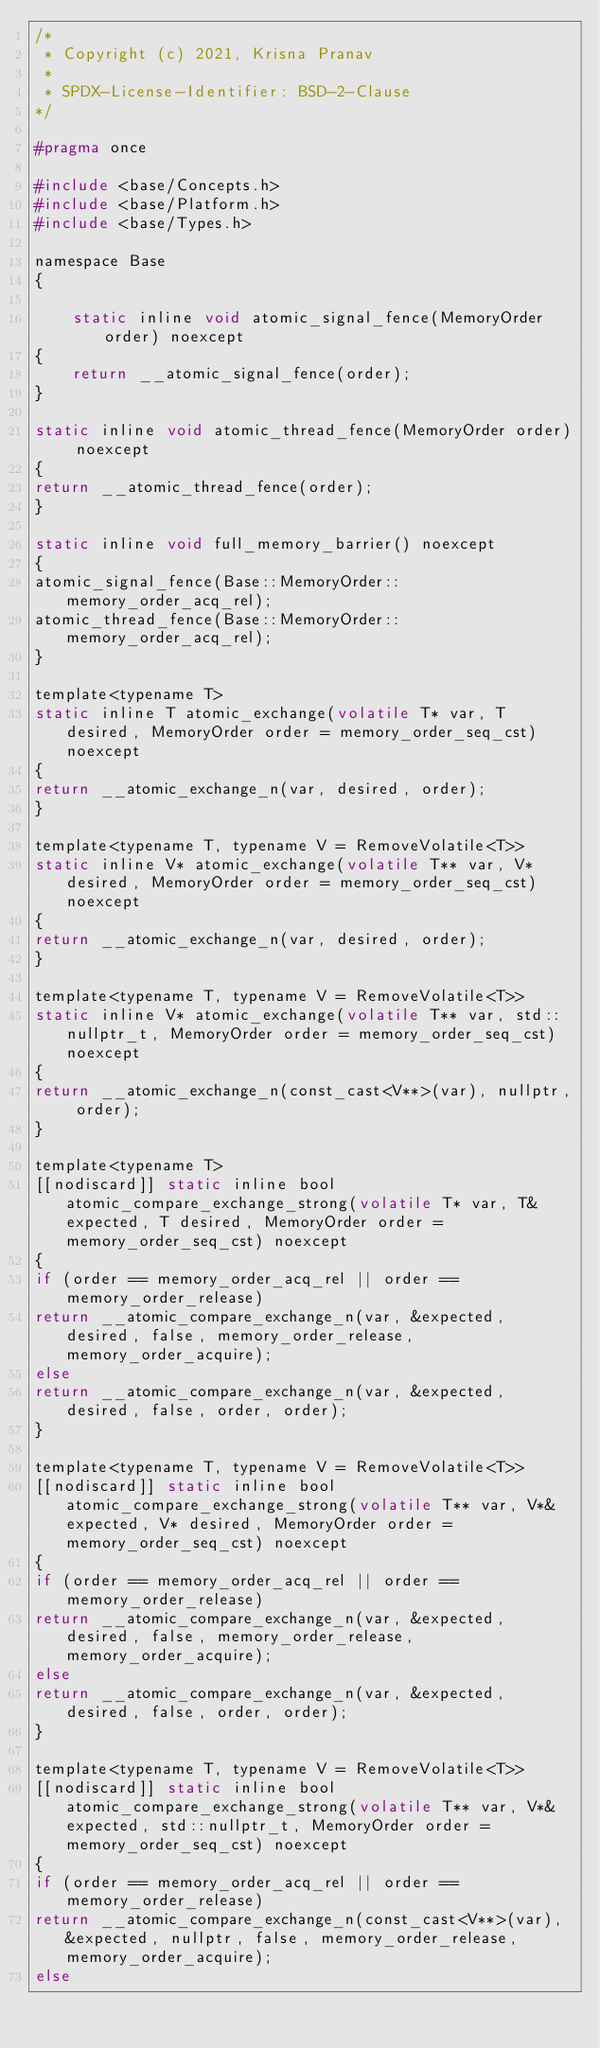<code> <loc_0><loc_0><loc_500><loc_500><_C_>/*
 * Copyright (c) 2021, Krisna Pranav
 *
 * SPDX-License-Identifier: BSD-2-Clause
*/

#pragma once

#include <base/Concepts.h>
#include <base/Platform.h>
#include <base/Types.h>

namespace Base 
{

    static inline void atomic_signal_fence(MemoryOrder order) noexcept
{
    return __atomic_signal_fence(order);
}

static inline void atomic_thread_fence(MemoryOrder order) noexcept
{
return __atomic_thread_fence(order);
}

static inline void full_memory_barrier() noexcept
{
atomic_signal_fence(Base::MemoryOrder::memory_order_acq_rel);
atomic_thread_fence(Base::MemoryOrder::memory_order_acq_rel);
}

template<typename T>
static inline T atomic_exchange(volatile T* var, T desired, MemoryOrder order = memory_order_seq_cst) noexcept
{
return __atomic_exchange_n(var, desired, order);
}

template<typename T, typename V = RemoveVolatile<T>>
static inline V* atomic_exchange(volatile T** var, V* desired, MemoryOrder order = memory_order_seq_cst) noexcept
{
return __atomic_exchange_n(var, desired, order);
}

template<typename T, typename V = RemoveVolatile<T>>
static inline V* atomic_exchange(volatile T** var, std::nullptr_t, MemoryOrder order = memory_order_seq_cst) noexcept
{
return __atomic_exchange_n(const_cast<V**>(var), nullptr, order);
}

template<typename T>
[[nodiscard]] static inline bool atomic_compare_exchange_strong(volatile T* var, T& expected, T desired, MemoryOrder order = memory_order_seq_cst) noexcept
{
if (order == memory_order_acq_rel || order == memory_order_release)
return __atomic_compare_exchange_n(var, &expected, desired, false, memory_order_release, memory_order_acquire);
else
return __atomic_compare_exchange_n(var, &expected, desired, false, order, order);
}

template<typename T, typename V = RemoveVolatile<T>>
[[nodiscard]] static inline bool atomic_compare_exchange_strong(volatile T** var, V*& expected, V* desired, MemoryOrder order = memory_order_seq_cst) noexcept
{
if (order == memory_order_acq_rel || order == memory_order_release)
return __atomic_compare_exchange_n(var, &expected, desired, false, memory_order_release, memory_order_acquire);
else
return __atomic_compare_exchange_n(var, &expected, desired, false, order, order);
}

template<typename T, typename V = RemoveVolatile<T>>
[[nodiscard]] static inline bool atomic_compare_exchange_strong(volatile T** var, V*& expected, std::nullptr_t, MemoryOrder order = memory_order_seq_cst) noexcept
{
if (order == memory_order_acq_rel || order == memory_order_release)
return __atomic_compare_exchange_n(const_cast<V**>(var), &expected, nullptr, false, memory_order_release, memory_order_acquire);
else</code> 